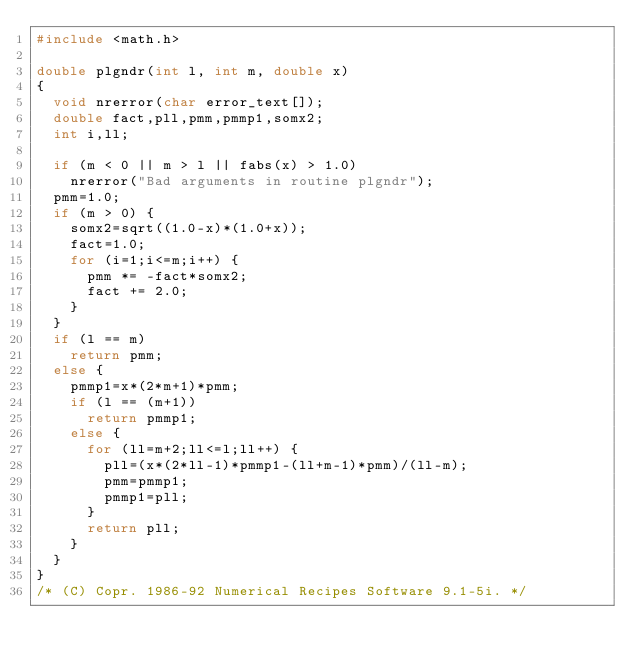<code> <loc_0><loc_0><loc_500><loc_500><_C_>#include <math.h>

double plgndr(int l, int m, double x)
{
	void nrerror(char error_text[]);
	double fact,pll,pmm,pmmp1,somx2;
	int i,ll;

	if (m < 0 || m > l || fabs(x) > 1.0)
		nrerror("Bad arguments in routine plgndr");
	pmm=1.0;
	if (m > 0) {
		somx2=sqrt((1.0-x)*(1.0+x));
		fact=1.0;
		for (i=1;i<=m;i++) {
			pmm *= -fact*somx2;
			fact += 2.0;
		}
	}
	if (l == m)
		return pmm;
	else {
		pmmp1=x*(2*m+1)*pmm;
		if (l == (m+1))
			return pmmp1;
		else {
			for (ll=m+2;ll<=l;ll++) {
				pll=(x*(2*ll-1)*pmmp1-(ll+m-1)*pmm)/(ll-m);
				pmm=pmmp1;
				pmmp1=pll;
			}
			return pll;
		}
	}
}
/* (C) Copr. 1986-92 Numerical Recipes Software 9.1-5i. */
</code> 